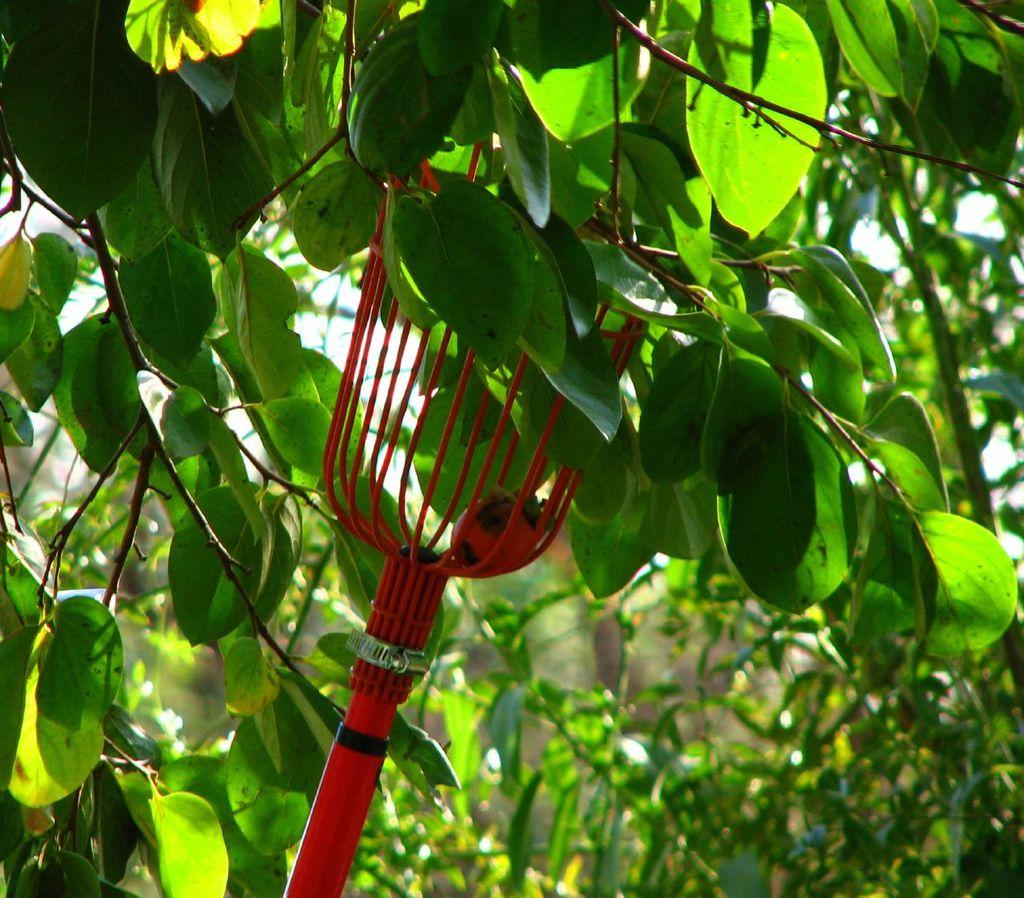What tool is shown in the image? There is a fruit harvester tool in the image. What type of plant material can be seen in the image? Leaves and stems are visible in the image. What is the purpose of the fruit harvester tool? The fruit harvester tool is used to pick fruits. Is there any fruit present in the image? Yes, there is a fruit inside the fruit harvester tool. What country is depicted in the image? There is no country depicted in the image; it features a fruit harvester tool and plant materials. Can you tell me what type of vase is present in the image? There is no vase present in the image. 